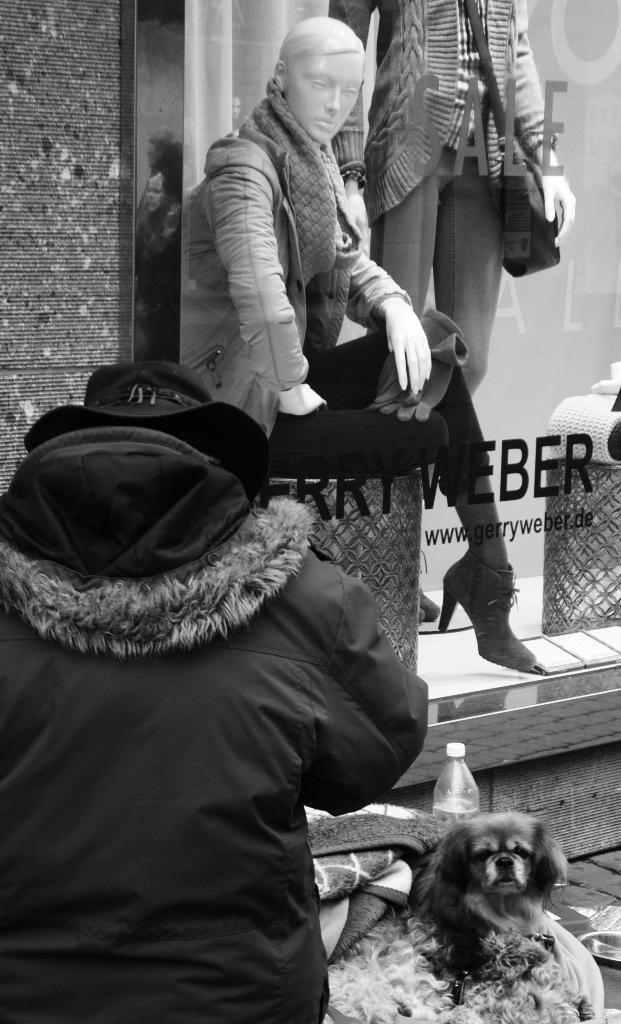How would you summarize this image in a sentence or two? In this image we can see the black and white image and we can see a person and to the side there is a dog and some other objects. We can see a building and there are two mannequins and it looks like a store and there is some text on the glass. 